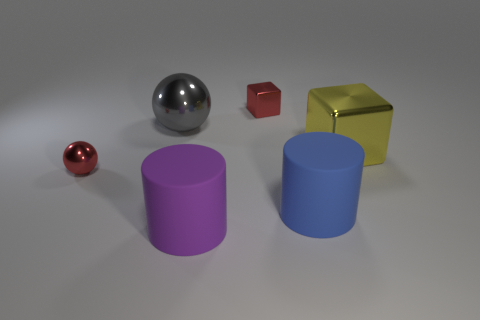Add 3 red balls. How many objects exist? 9 Subtract all blocks. How many objects are left? 4 Add 2 red balls. How many red balls are left? 3 Add 2 purple metallic blocks. How many purple metallic blocks exist? 2 Subtract 0 purple balls. How many objects are left? 6 Subtract all blocks. Subtract all purple things. How many objects are left? 3 